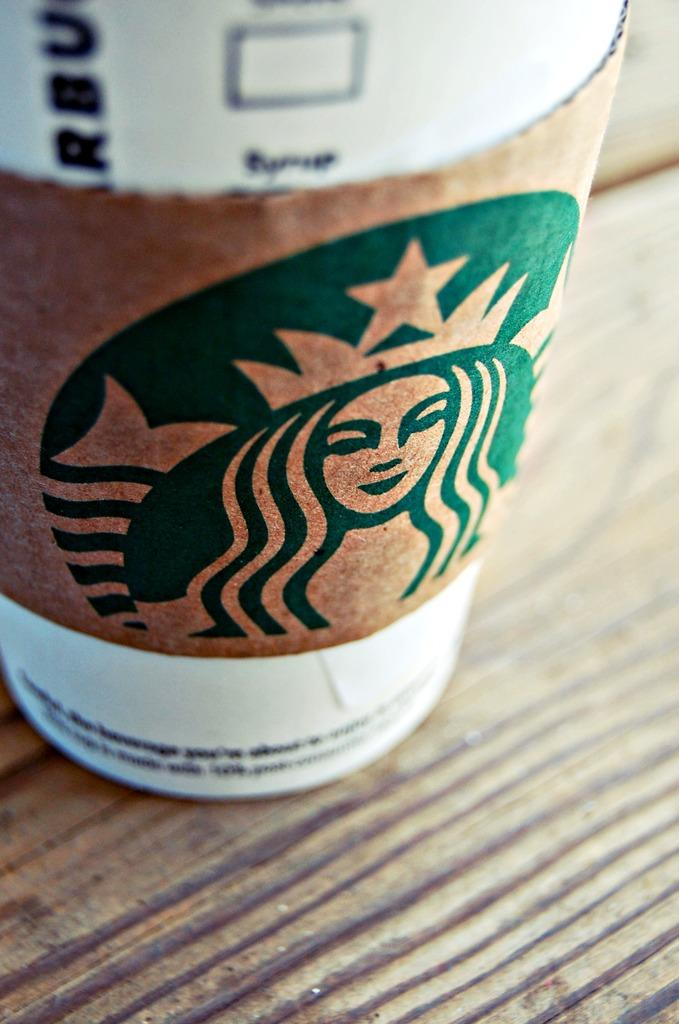What object is visible on the table in the image? There is a cup on the table in the image. What else is on the table besides the cup? A woman's painting is on the table. Where is the image taken? The image is taken inside a room. What type of dog can be seen playing with a duck in the aftermath of the image? There is no dog, duck, or any aftermath depicted in the image; it only features a cup and a woman's painting on a table inside a room. 